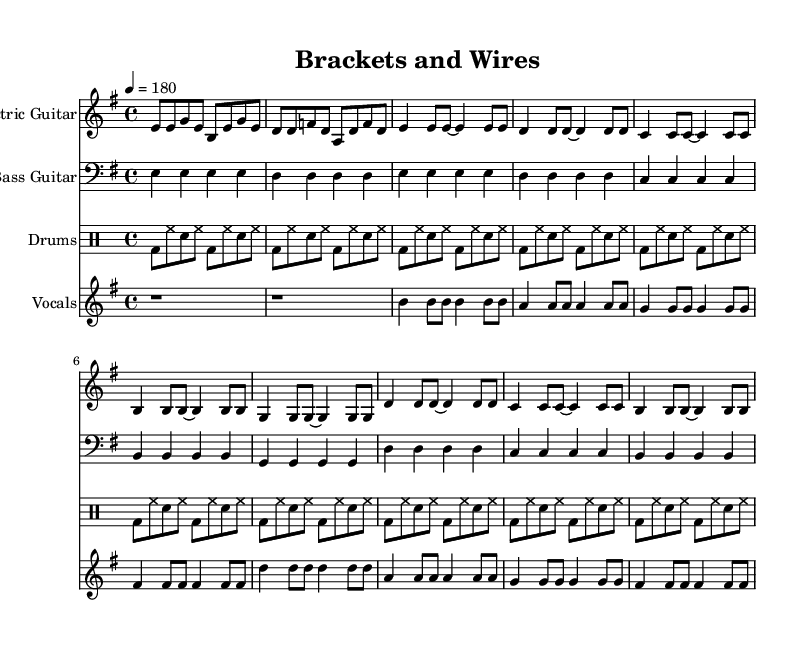What is the key signature of this music? The key signature is indicated at the beginning of the staff, showing E minor. This is determined by the presence of one sharp (F#) in the key signature, which is characteristic of E minor.
Answer: E minor What is the time signature of this music? The time signature is located at the beginning of the music, shown as 4/4. This indicates that there are 4 beats in a measure, and each beat is a quarter note in length.
Answer: 4/4 What is the tempo marking given in the sheet music? The tempo marking appears above the staff as "4 = 180," meaning the quarter note should be played at a speed of 180 beats per minute, which denotes a fast pace typical of punk music.
Answer: 180 How many measures are there in the electric guitar part? By counting the measures indicated in the electric guitar notation, there are a total of 10 measures, which can be confirmed by recognizing the patterns and structure laid out within the provided notes.
Answer: 10 What type of instrument is labeled for the first staff? The first staff is designated for an "Electric Guitar," indicated by the annotation at the start of that staff. This tells us which instrument is to play the notes on that staff.
Answer: Electric Guitar What is the vocal range indicated for the vocal staff? The vocal staff begins at a relative C'' and spans down through the notes in the melody, demonstrating a typical range for a vocalist, particularly showing use of higher pitches suitable for the punk genre.
Answer: C'' What phrase is repeated in the lyrics of the song? The phrase "Straighten up and align your smile," appears twice in the lyrics and reflects the theme of orthodontic innovation; this is noted in the repetition of the first line and key message.
Answer: "Straighten up and align your smile." 